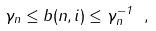Convert formula to latex. <formula><loc_0><loc_0><loc_500><loc_500>\gamma _ { n } \leq b ( n , i ) \leq \gamma _ { n } ^ { - 1 } \ ,</formula> 